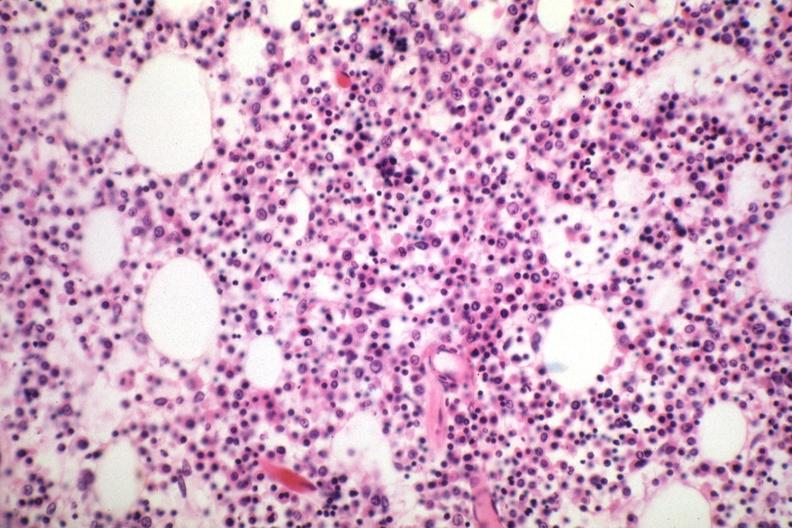how is marrow loaded with plasma cells that are?
Answer the question using a single word or phrase. Immature 